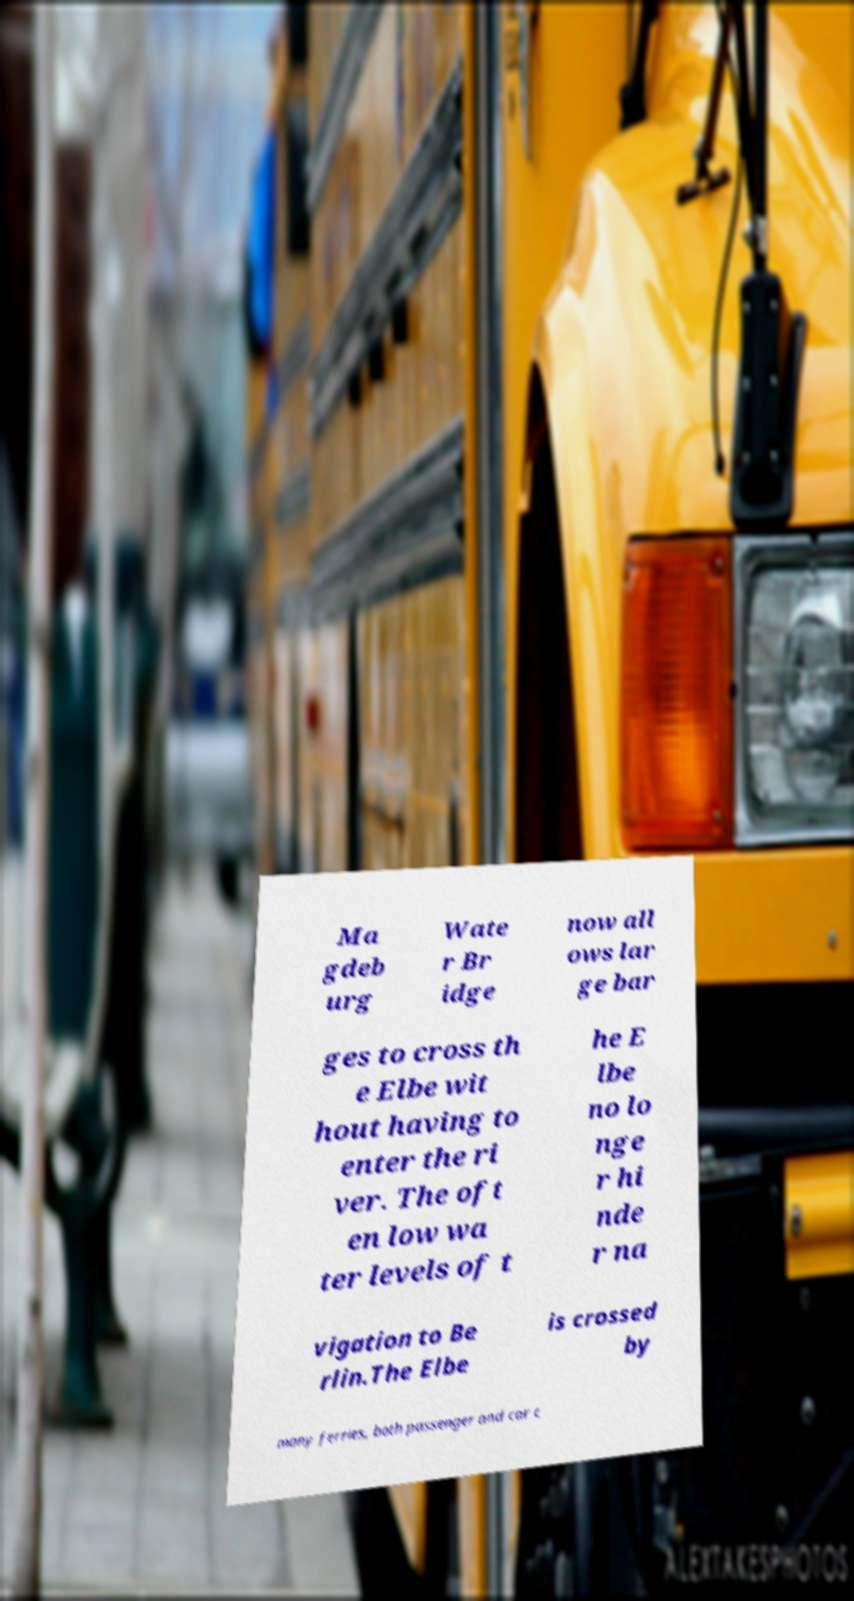Can you accurately transcribe the text from the provided image for me? Ma gdeb urg Wate r Br idge now all ows lar ge bar ges to cross th e Elbe wit hout having to enter the ri ver. The oft en low wa ter levels of t he E lbe no lo nge r hi nde r na vigation to Be rlin.The Elbe is crossed by many ferries, both passenger and car c 